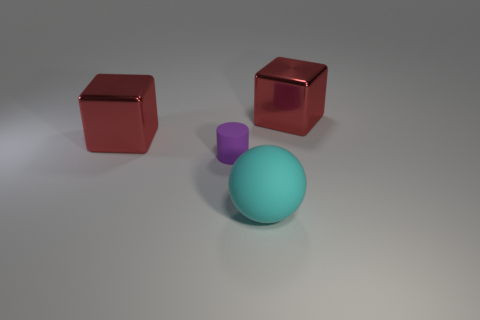What time of day does the lighting in the image suggest? The lighting in the image appears artificial, likely coming from a single overhead light source. This suggests that the image could've been taken indoors at any time of day under controlled lighting conditions. 